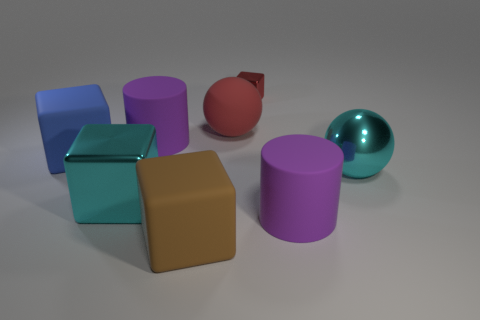What number of other things are the same material as the blue block?
Your answer should be very brief. 4. What is the color of the big cylinder right of the red thing that is left of the tiny red thing?
Offer a very short reply. Purple. There is a large metal thing right of the large metallic block; is it the same color as the big metal block?
Make the answer very short. Yes. Do the brown cube and the red rubber object have the same size?
Your answer should be very brief. Yes. There is a blue thing that is the same size as the brown matte thing; what shape is it?
Make the answer very short. Cube. Is the size of the matte cube to the right of the blue object the same as the tiny red object?
Make the answer very short. No. There is a red object that is the same size as the brown matte block; what material is it?
Your answer should be compact. Rubber. There is a rubber cube in front of the big cyan object to the left of the tiny red metallic block; is there a large blue block that is behind it?
Keep it short and to the point. Yes. Do the cylinder to the right of the red rubber sphere and the large cylinder to the left of the tiny cube have the same color?
Give a very brief answer. Yes. Is there a tiny gray matte cube?
Keep it short and to the point. No. 